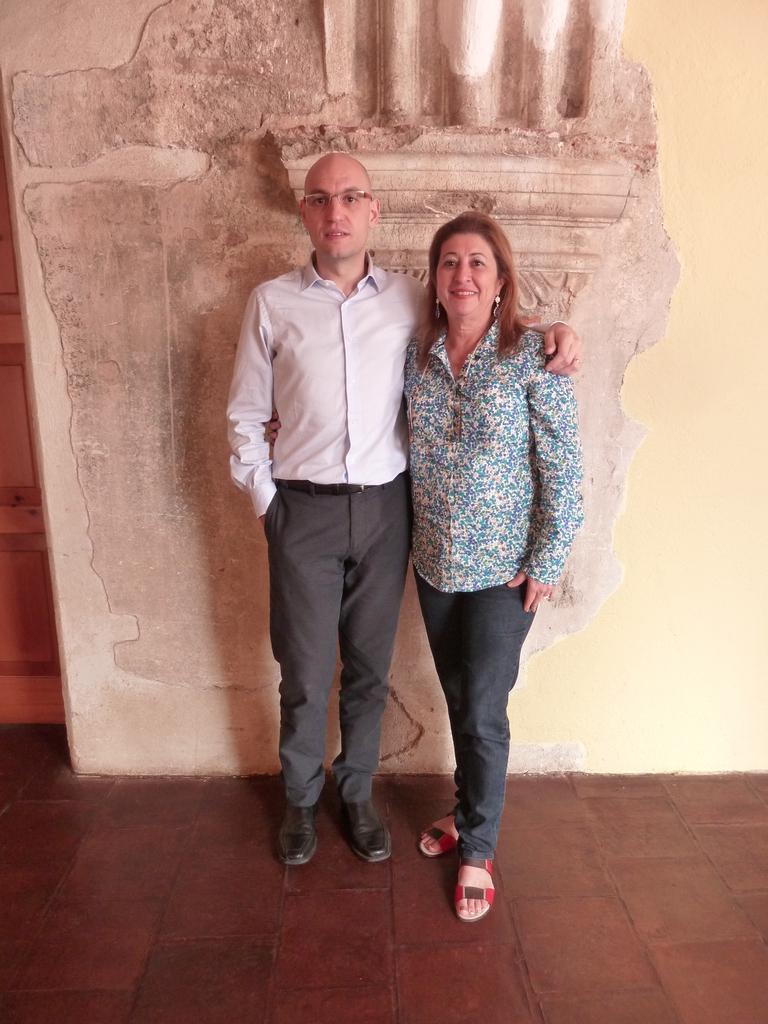Please provide a concise description of this image. In the center of the image we can see two people are standing. In the background of the image we can see the wall. On the left side of the image we can see a door. At the bottom of the image we can see the floor. 